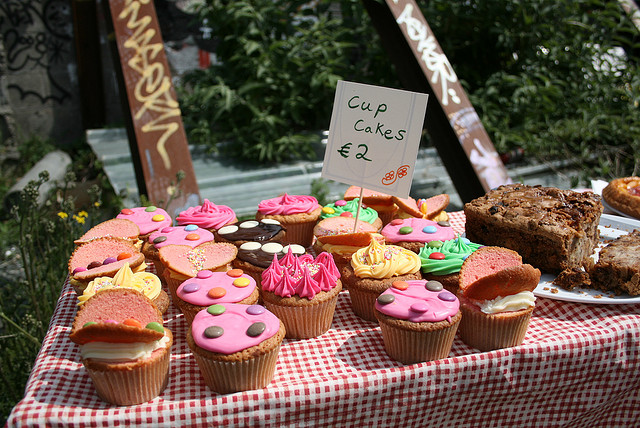Extract all visible text content from this image. Cup Cakes 2 